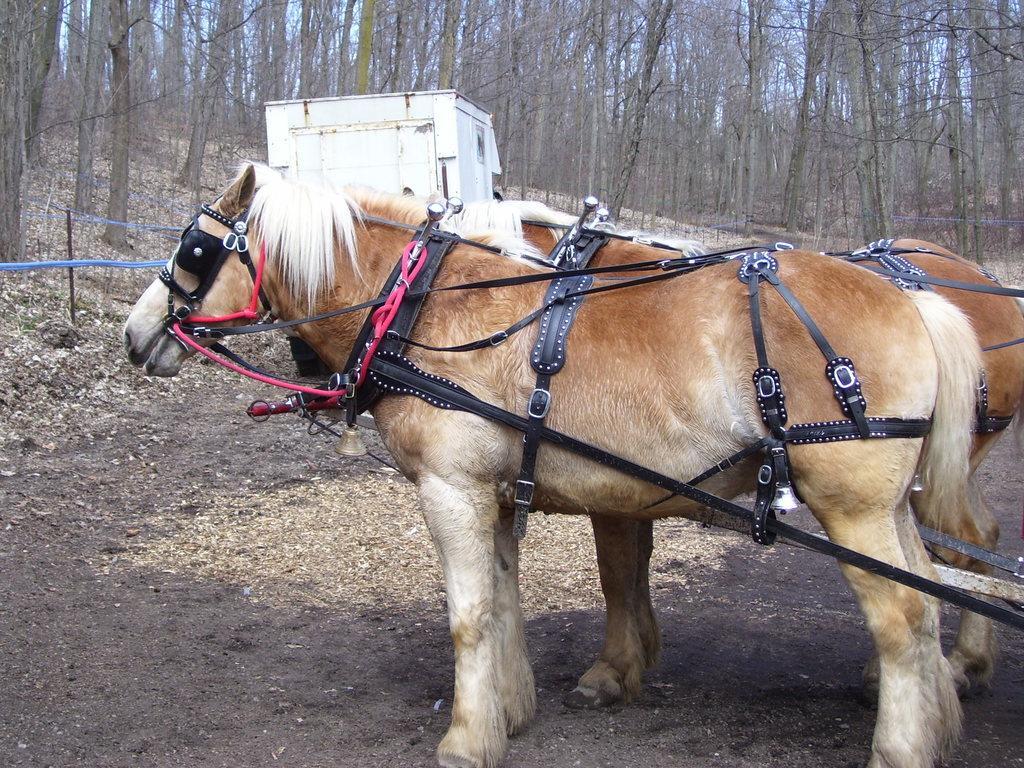Can you describe this image briefly? In this image, there are a few animals. We can see the ground with some objects. There are a few trees. We can see the sky and a pole with some cloth. 